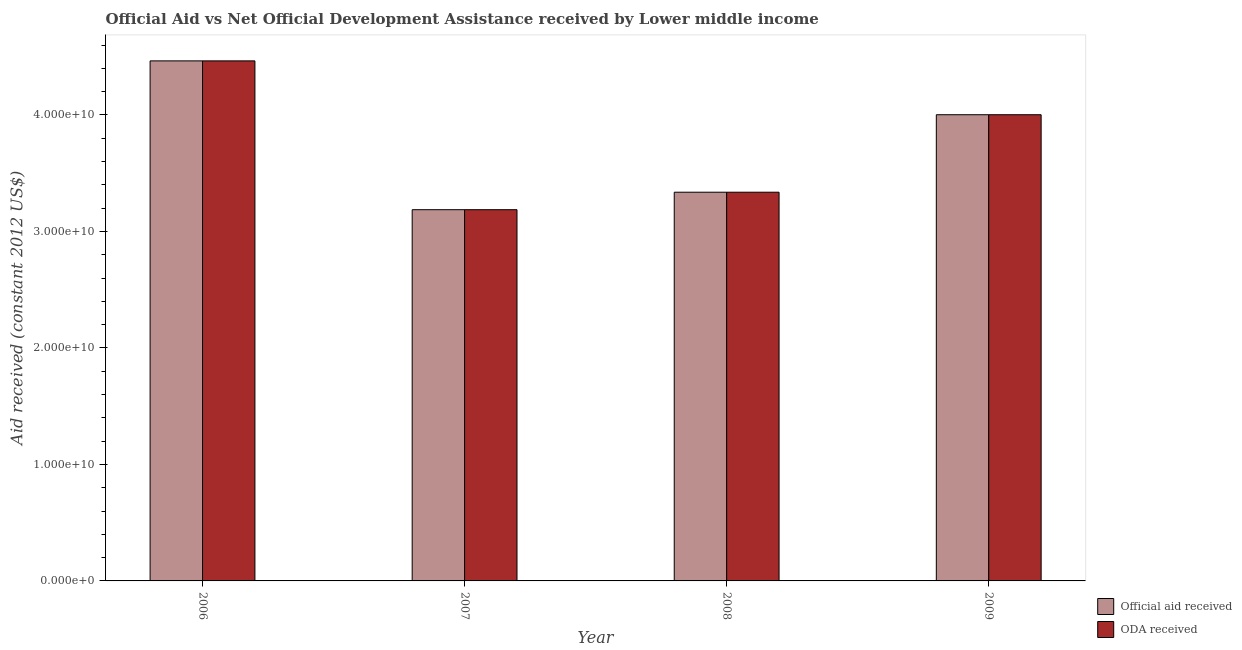How many different coloured bars are there?
Provide a succinct answer. 2. Are the number of bars on each tick of the X-axis equal?
Your response must be concise. Yes. How many bars are there on the 1st tick from the right?
Keep it short and to the point. 2. What is the label of the 1st group of bars from the left?
Your response must be concise. 2006. In how many cases, is the number of bars for a given year not equal to the number of legend labels?
Make the answer very short. 0. What is the oda received in 2009?
Give a very brief answer. 4.00e+1. Across all years, what is the maximum oda received?
Keep it short and to the point. 4.46e+1. Across all years, what is the minimum official aid received?
Your response must be concise. 3.19e+1. What is the total oda received in the graph?
Make the answer very short. 1.50e+11. What is the difference between the oda received in 2007 and that in 2009?
Offer a very short reply. -8.15e+09. What is the difference between the oda received in 2006 and the official aid received in 2009?
Provide a succinct answer. 4.62e+09. What is the average official aid received per year?
Make the answer very short. 3.75e+1. In the year 2008, what is the difference between the oda received and official aid received?
Provide a short and direct response. 0. What is the ratio of the oda received in 2006 to that in 2009?
Keep it short and to the point. 1.12. Is the official aid received in 2006 less than that in 2009?
Provide a short and direct response. No. Is the difference between the official aid received in 2007 and 2009 greater than the difference between the oda received in 2007 and 2009?
Make the answer very short. No. What is the difference between the highest and the second highest official aid received?
Provide a succinct answer. 4.62e+09. What is the difference between the highest and the lowest official aid received?
Provide a short and direct response. 1.28e+1. In how many years, is the official aid received greater than the average official aid received taken over all years?
Your answer should be very brief. 2. What does the 2nd bar from the left in 2009 represents?
Your answer should be compact. ODA received. What does the 2nd bar from the right in 2006 represents?
Provide a succinct answer. Official aid received. How many bars are there?
Provide a short and direct response. 8. How many years are there in the graph?
Keep it short and to the point. 4. What is the difference between two consecutive major ticks on the Y-axis?
Your response must be concise. 1.00e+1. Does the graph contain grids?
Your response must be concise. No. Where does the legend appear in the graph?
Ensure brevity in your answer.  Bottom right. How are the legend labels stacked?
Your answer should be very brief. Vertical. What is the title of the graph?
Make the answer very short. Official Aid vs Net Official Development Assistance received by Lower middle income . What is the label or title of the X-axis?
Keep it short and to the point. Year. What is the label or title of the Y-axis?
Provide a short and direct response. Aid received (constant 2012 US$). What is the Aid received (constant 2012 US$) in Official aid received in 2006?
Your response must be concise. 4.46e+1. What is the Aid received (constant 2012 US$) in ODA received in 2006?
Provide a succinct answer. 4.46e+1. What is the Aid received (constant 2012 US$) in Official aid received in 2007?
Make the answer very short. 3.19e+1. What is the Aid received (constant 2012 US$) of ODA received in 2007?
Your response must be concise. 3.19e+1. What is the Aid received (constant 2012 US$) of Official aid received in 2008?
Keep it short and to the point. 3.34e+1. What is the Aid received (constant 2012 US$) in ODA received in 2008?
Provide a short and direct response. 3.34e+1. What is the Aid received (constant 2012 US$) of Official aid received in 2009?
Give a very brief answer. 4.00e+1. What is the Aid received (constant 2012 US$) of ODA received in 2009?
Provide a succinct answer. 4.00e+1. Across all years, what is the maximum Aid received (constant 2012 US$) of Official aid received?
Your answer should be very brief. 4.46e+1. Across all years, what is the maximum Aid received (constant 2012 US$) of ODA received?
Your answer should be very brief. 4.46e+1. Across all years, what is the minimum Aid received (constant 2012 US$) in Official aid received?
Provide a short and direct response. 3.19e+1. Across all years, what is the minimum Aid received (constant 2012 US$) in ODA received?
Your response must be concise. 3.19e+1. What is the total Aid received (constant 2012 US$) of Official aid received in the graph?
Offer a very short reply. 1.50e+11. What is the total Aid received (constant 2012 US$) in ODA received in the graph?
Provide a short and direct response. 1.50e+11. What is the difference between the Aid received (constant 2012 US$) of Official aid received in 2006 and that in 2007?
Your answer should be compact. 1.28e+1. What is the difference between the Aid received (constant 2012 US$) of ODA received in 2006 and that in 2007?
Your answer should be very brief. 1.28e+1. What is the difference between the Aid received (constant 2012 US$) of Official aid received in 2006 and that in 2008?
Provide a succinct answer. 1.13e+1. What is the difference between the Aid received (constant 2012 US$) of ODA received in 2006 and that in 2008?
Make the answer very short. 1.13e+1. What is the difference between the Aid received (constant 2012 US$) of Official aid received in 2006 and that in 2009?
Your response must be concise. 4.62e+09. What is the difference between the Aid received (constant 2012 US$) of ODA received in 2006 and that in 2009?
Provide a short and direct response. 4.62e+09. What is the difference between the Aid received (constant 2012 US$) in Official aid received in 2007 and that in 2008?
Provide a short and direct response. -1.50e+09. What is the difference between the Aid received (constant 2012 US$) in ODA received in 2007 and that in 2008?
Keep it short and to the point. -1.50e+09. What is the difference between the Aid received (constant 2012 US$) in Official aid received in 2007 and that in 2009?
Give a very brief answer. -8.15e+09. What is the difference between the Aid received (constant 2012 US$) of ODA received in 2007 and that in 2009?
Keep it short and to the point. -8.15e+09. What is the difference between the Aid received (constant 2012 US$) of Official aid received in 2008 and that in 2009?
Your response must be concise. -6.65e+09. What is the difference between the Aid received (constant 2012 US$) of ODA received in 2008 and that in 2009?
Make the answer very short. -6.65e+09. What is the difference between the Aid received (constant 2012 US$) in Official aid received in 2006 and the Aid received (constant 2012 US$) in ODA received in 2007?
Your answer should be very brief. 1.28e+1. What is the difference between the Aid received (constant 2012 US$) in Official aid received in 2006 and the Aid received (constant 2012 US$) in ODA received in 2008?
Keep it short and to the point. 1.13e+1. What is the difference between the Aid received (constant 2012 US$) in Official aid received in 2006 and the Aid received (constant 2012 US$) in ODA received in 2009?
Offer a very short reply. 4.62e+09. What is the difference between the Aid received (constant 2012 US$) in Official aid received in 2007 and the Aid received (constant 2012 US$) in ODA received in 2008?
Keep it short and to the point. -1.50e+09. What is the difference between the Aid received (constant 2012 US$) of Official aid received in 2007 and the Aid received (constant 2012 US$) of ODA received in 2009?
Your answer should be very brief. -8.15e+09. What is the difference between the Aid received (constant 2012 US$) in Official aid received in 2008 and the Aid received (constant 2012 US$) in ODA received in 2009?
Give a very brief answer. -6.65e+09. What is the average Aid received (constant 2012 US$) in Official aid received per year?
Your answer should be very brief. 3.75e+1. What is the average Aid received (constant 2012 US$) in ODA received per year?
Ensure brevity in your answer.  3.75e+1. What is the ratio of the Aid received (constant 2012 US$) in Official aid received in 2006 to that in 2007?
Your answer should be very brief. 1.4. What is the ratio of the Aid received (constant 2012 US$) in ODA received in 2006 to that in 2007?
Give a very brief answer. 1.4. What is the ratio of the Aid received (constant 2012 US$) of Official aid received in 2006 to that in 2008?
Provide a succinct answer. 1.34. What is the ratio of the Aid received (constant 2012 US$) of ODA received in 2006 to that in 2008?
Keep it short and to the point. 1.34. What is the ratio of the Aid received (constant 2012 US$) in Official aid received in 2006 to that in 2009?
Your answer should be very brief. 1.12. What is the ratio of the Aid received (constant 2012 US$) of ODA received in 2006 to that in 2009?
Give a very brief answer. 1.12. What is the ratio of the Aid received (constant 2012 US$) of Official aid received in 2007 to that in 2008?
Provide a short and direct response. 0.95. What is the ratio of the Aid received (constant 2012 US$) of ODA received in 2007 to that in 2008?
Give a very brief answer. 0.95. What is the ratio of the Aid received (constant 2012 US$) of Official aid received in 2007 to that in 2009?
Offer a terse response. 0.8. What is the ratio of the Aid received (constant 2012 US$) in ODA received in 2007 to that in 2009?
Your answer should be compact. 0.8. What is the ratio of the Aid received (constant 2012 US$) in Official aid received in 2008 to that in 2009?
Make the answer very short. 0.83. What is the ratio of the Aid received (constant 2012 US$) in ODA received in 2008 to that in 2009?
Your response must be concise. 0.83. What is the difference between the highest and the second highest Aid received (constant 2012 US$) in Official aid received?
Your answer should be compact. 4.62e+09. What is the difference between the highest and the second highest Aid received (constant 2012 US$) of ODA received?
Provide a short and direct response. 4.62e+09. What is the difference between the highest and the lowest Aid received (constant 2012 US$) in Official aid received?
Provide a short and direct response. 1.28e+1. What is the difference between the highest and the lowest Aid received (constant 2012 US$) in ODA received?
Provide a short and direct response. 1.28e+1. 